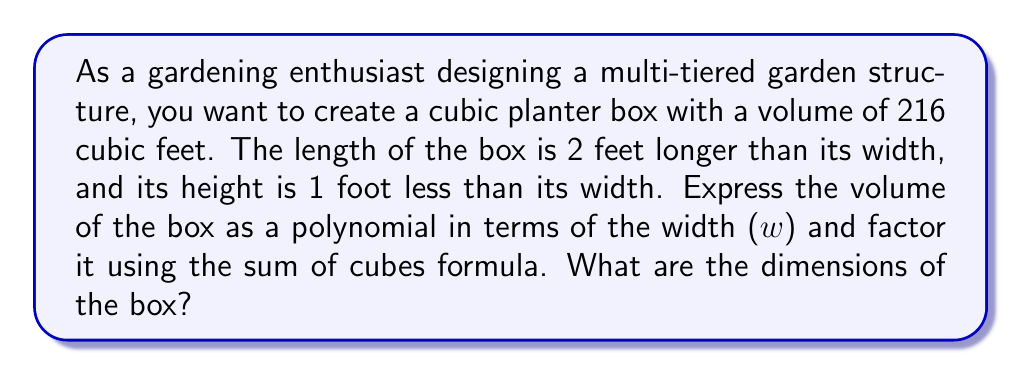Provide a solution to this math problem. Let's approach this step-by-step:

1) First, let's express the dimensions in terms of w:
   Width = w
   Length = w + 2
   Height = w - 1

2) The volume of a rectangular box is given by length × width × height:
   $$V = (w + 2) \cdot w \cdot (w - 1)$$

3) Expanding this expression:
   $$V = w^3 + 2w^2 - w^2 - 2w = w^3 + w^2 - 2w$$

4) We're told that the volume is 216 cubic feet, so:
   $$w^3 + w^2 - 2w - 216 = 0$$

5) This is where we can use the sum of cubes formula. The sum of cubes formula is:
   $$a^3 + b^3 = (a + b)(a^2 - ab + b^2)$$

6) In our case, $a^3 = w^3$ and $b^3 = 216$. So, $a = w$ and $b = 6$.

7) Rewriting our equation:
   $$w^3 + 216 + w^2 - 2w - 216 = 0$$
   $$(w^3 + 216) + (w^2 - 2w - 216) = 0$$

8) Applying the sum of cubes formula:
   $$(w + 6)(w^2 - 6w + 36) + (w^2 - 2w - 216) = 0$$

9) Factoring further:
   $$(w + 6)(w^2 - 6w + 36) + (w - 12)(w + 10) = 0$$
   $$(w + 6)(w - 6)^2 = 0$$

10) Solving this equation:
    $w + 6 = 0$ or $w - 6 = 0$
    $w = -6$ or $w = 6$

11) Since width can't be negative, $w = 6$ feet.

Therefore, the dimensions are:
Width = 6 feet
Length = 6 + 2 = 8 feet
Height = 6 - 1 = 5 feet
Answer: The dimensions of the cubic planter box are 8 feet long, 6 feet wide, and 5 feet high. 